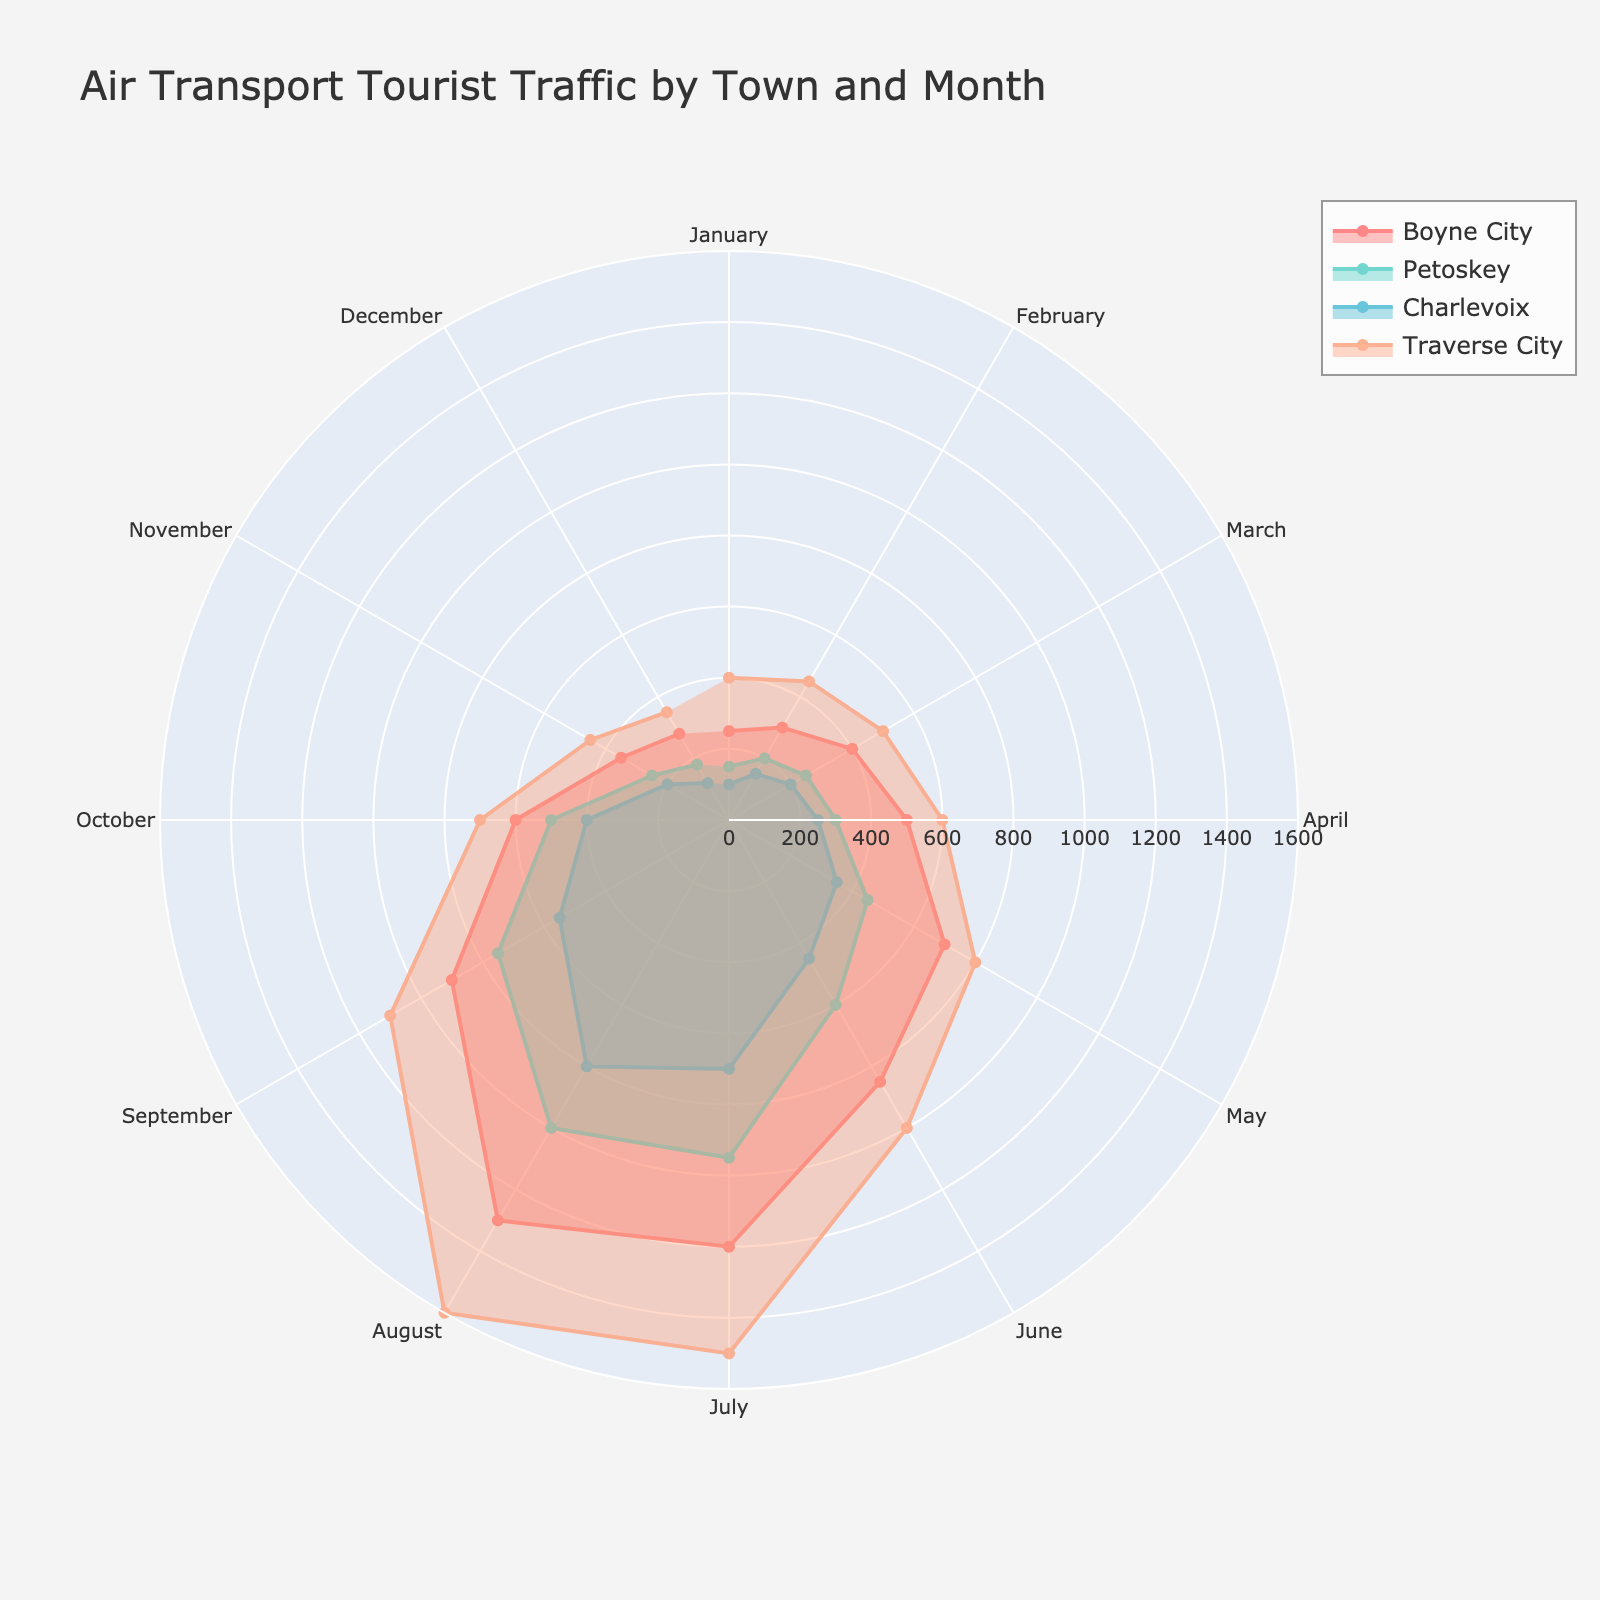What's the title of the figure? The question asks for the title of the figure, which is typically displayed at the top. By observing the figure, you can see that the title is specifically mentioned.
Answer: Air Transport Tourist Traffic by Town and Month Which town has the highest number of air transport tourists in July? In the figure, July's data points are given for each town. By comparing the values for July, we can see that Boyne City has the highest number of tourists.
Answer: Boyne City What is the trend of air transport tourists in Boyne City from January to December? To answer this, observe the data points for Boyne City in all months and describe the trend. The number of tourists starts low in January, peaks in August, and then drops towards December.
Answer: Increasing till August, then decreasing Which month sees the peak number of tourists in Traverse City? Compare the values for Traverse City across all months to identify the highest value. August has the highest number of tourists for Traverse City.
Answer: August Compare the air transport tourist numbers between Boyne City and Petoskey in June. Look at the June values for both Boyne City and Petoskey. Boyne City has 850 tourists, while Petoskey has 600. So, Boyne City has higher numbers.
Answer: Boyne City has more What is the average number of air transport tourists for Charlevoix in the summer months (June, July, August)? Add the tourist numbers for Charlevoix in June, July, and August (450 + 700 + 800) and then divide by 3 to get the average. (450 + 700 + 800) / 3 = 1950 / 3 = 650
Answer: 650 Is the number of tourists in Boyne City higher in May than in October? Compare the values for Boyne City in May (700) and October (600), and you find that May has a higher number.
Answer: Yes Which town shows the least variation in air transport tourists throughout the year? By observing the spread of data points for each town, Traverse City shows the least variation because its values are relatively more consistent compared to others.
Answer: Traverse City In which month does Charlevoix receive half of Boyne City's numbers? Compare the values for both towns. Charlevoix in August (800) is closest to half of Boyne City in August (1300). Half of 1300 is 650, so August is the closest.
Answer: August 